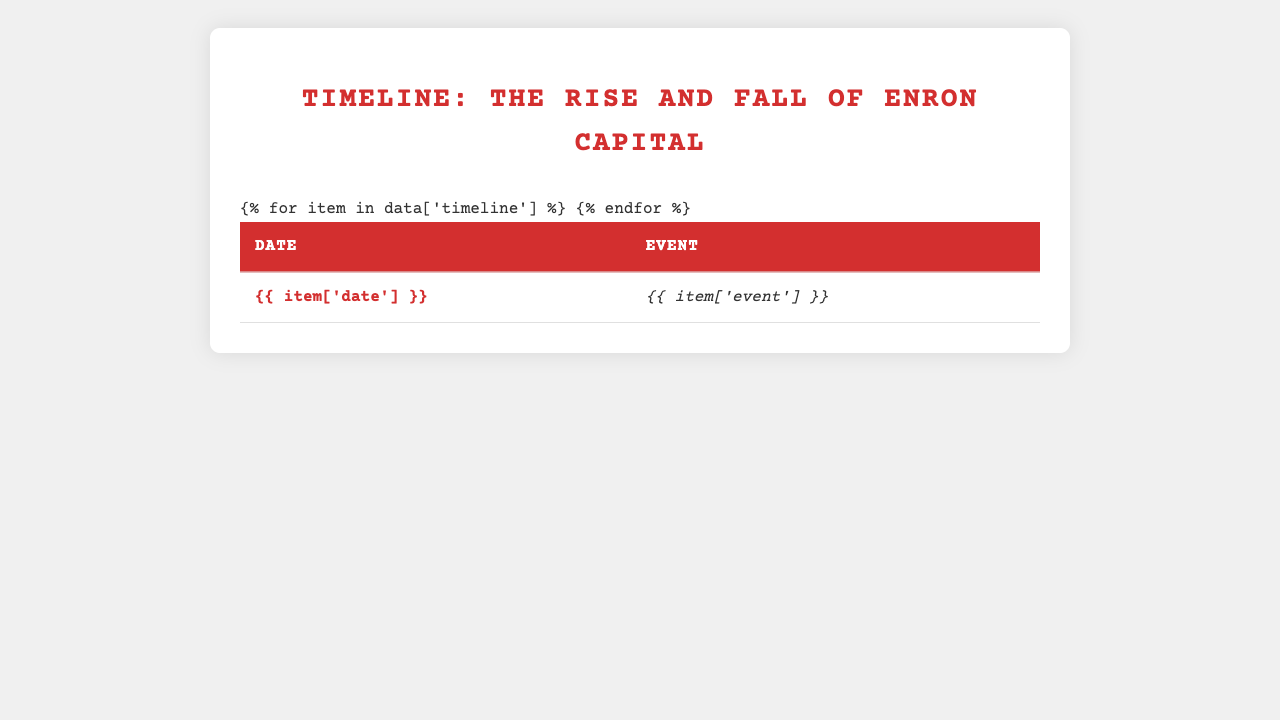What date was Enron Capital founded? Referring to the table, the event labeled "Enron Capital LLC founded by CEO Marcus Winters" has the date "2015-03-12."
Answer: 2015-03-12 What significant event occurred on 2017-02-15? The table shows that on this date, the "Wall Street Journal publishes exposé on questionable accounting practices."
Answer: Wall Street Journal publishes exposé on questionable accounting practices How many years passed between the founding of Enron Capital and its filing for bankruptcy? Enron Capital was founded in 2015 and filed for bankruptcy in 2018. The difference is 3 years (2018 - 2015).
Answer: 3 years When did Marcus Winters get arrested? According to the table, Marcus Winters was arrested on 2017-09-14.
Answer: 2017-09-14 Is it true that Sarah Chen resigned before the SEC launched its formal investigation? The table shows Sarah Chen resigned on 2017-04-18, and the SEC launched the investigation on 2017-03-01. Since April 18 is after March 1, the statement is false.
Answer: No Count the total number of events listed in the timeline. The table lists a total of 13 events from the founding of Enron Capital to Marcus Winters' sentencing.
Answer: 13 events On what date did the trial for United States v. Winters et al. start? The table indicates that the trial begins on 2018-11-12.
Answer: 2018-11-12 What was the outcome of the trial for Marcus Winters? The table states that on 2019-02-28, the jury found Marcus Winters guilty on all counts.
Answer: Guilty on all counts What was the time span from the formal investigation by the SEC to the start of the trial? The SEC investigation began on 2017-03-01 and the trial started on 2018-11-12. The time span between these two dates is approximately 1 year and 8 months.
Answer: 1 year and 8 months How many individuals were indicted along with Marcus Winters? According to the table, Marcus Winters was indicted along with three other executives, totaling four individuals.
Answer: 4 individuals 